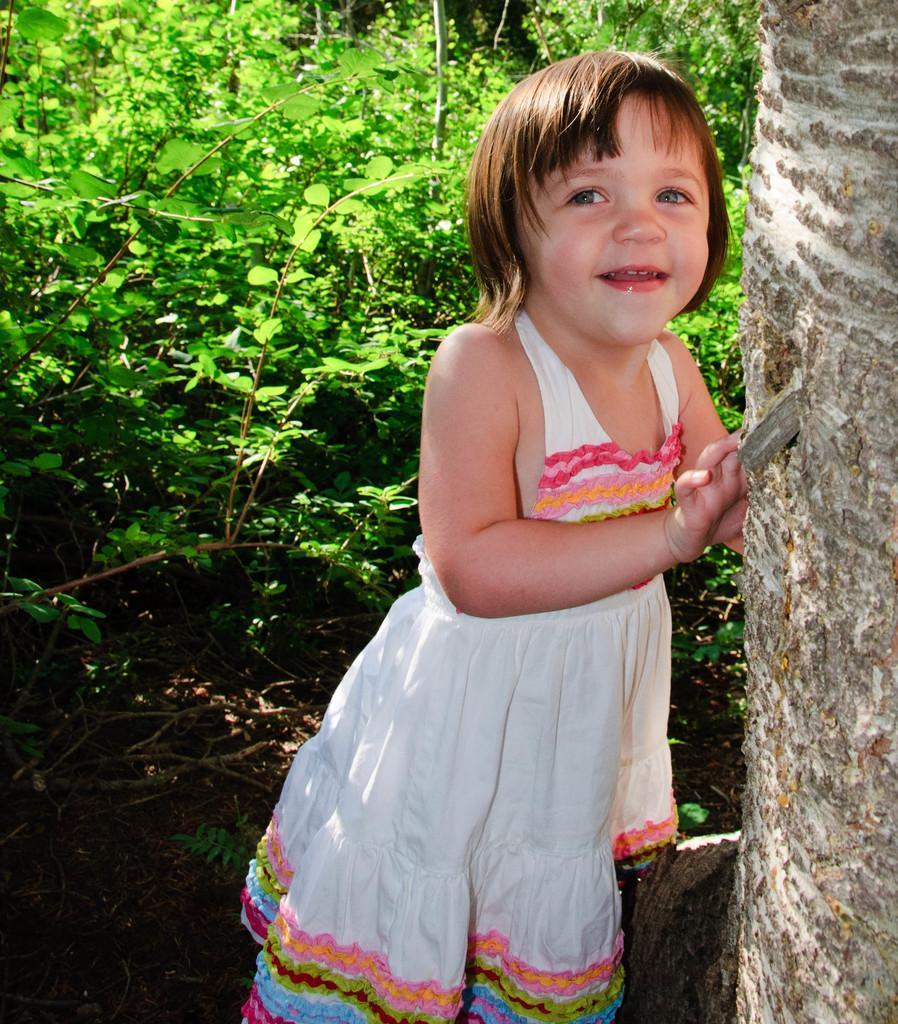Could you give a brief overview of what you see in this image? In this image there is a small girl standing beside the tree trunk behind her there are so many plants. 